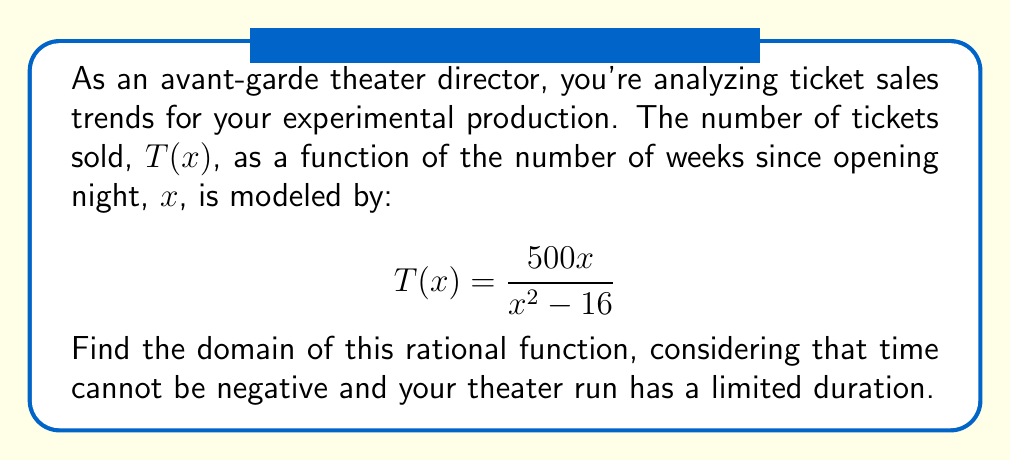Teach me how to tackle this problem. To find the domain of this rational function, we need to follow these steps:

1) The domain of a rational function includes all real numbers except those that make the denominator equal to zero.

2) Set the denominator equal to zero and solve:
   $$x^2 - 16 = 0$$
   $$(x+4)(x-4) = 0$$
   $$x = -4 \text{ or } x = 4$$

3) These values of $x$ are excluded from the domain.

4) Consider the context:
   - Time (weeks since opening) cannot be negative, so $x \geq 0$.
   - The theater run has a limited duration, let's assume it's no longer than 12 weeks.

5) Combining all these constraints, the domain is:
   $0 \leq x < 4$ and $4 < x \leq 12$

6) In interval notation, this is written as $[0,4) \cup (4,12]$
Answer: $[0,4) \cup (4,12]$ 